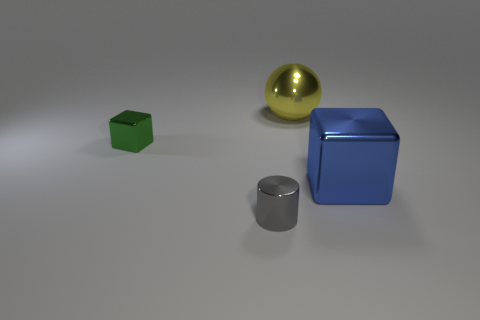Add 4 brown balls. How many objects exist? 8 Subtract all cylinders. How many objects are left? 3 Add 2 blue shiny things. How many blue shiny things exist? 3 Subtract 1 gray cylinders. How many objects are left? 3 Subtract all green rubber objects. Subtract all yellow shiny spheres. How many objects are left? 3 Add 3 small gray shiny things. How many small gray shiny things are left? 4 